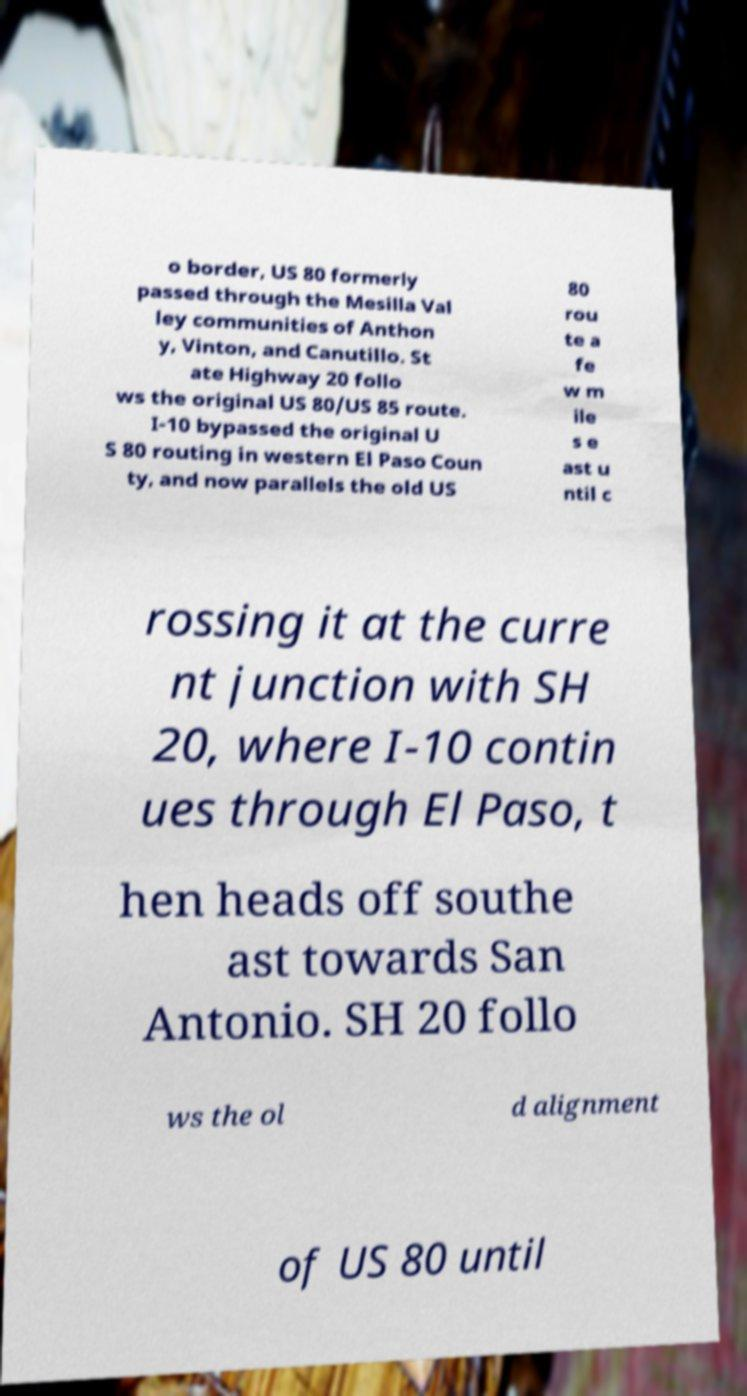Can you read and provide the text displayed in the image?This photo seems to have some interesting text. Can you extract and type it out for me? o border, US 80 formerly passed through the Mesilla Val ley communities of Anthon y, Vinton, and Canutillo. St ate Highway 20 follo ws the original US 80/US 85 route. I-10 bypassed the original U S 80 routing in western El Paso Coun ty, and now parallels the old US 80 rou te a fe w m ile s e ast u ntil c rossing it at the curre nt junction with SH 20, where I-10 contin ues through El Paso, t hen heads off southe ast towards San Antonio. SH 20 follo ws the ol d alignment of US 80 until 